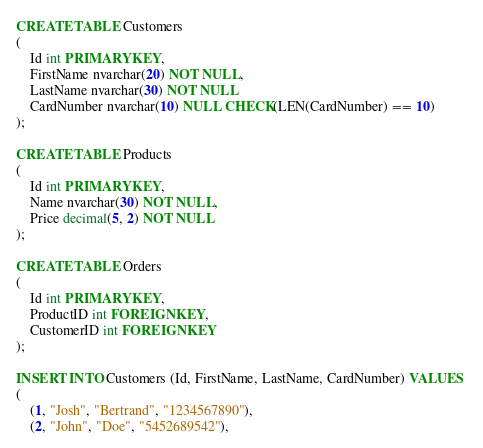Convert code to text. <code><loc_0><loc_0><loc_500><loc_500><_SQL_>CREATE TABLE Customers 
(
    Id int PRIMARY KEY,
    FirstName nvarchar(20) NOT NULL,
    LastName nvarchar(30) NOT NULL
    CardNumber nvarchar(10) NULL CHECK(LEN(CardNumber) == 10)
);

CREATE TABLE Products
(
    Id int PRIMARY KEY,
    Name nvarchar(30) NOT NULL,
    Price decimal(5, 2) NOT NULL
);

CREATE TABLE Orders
(
    Id int PRIMARY KEY,
    ProductID int FOREIGN KEY,
    CustomerID int FOREIGN KEY
);

INSERT INTO Customers (Id, FirstName, LastName, CardNumber) VALUES 
(
    (1, "Josh", "Bertrand", "1234567890"),
    (2, "John", "Doe", "5452689542"),</code> 